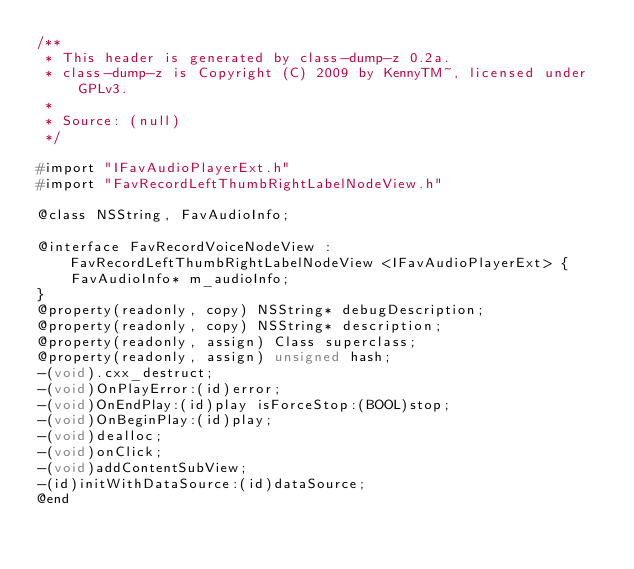Convert code to text. <code><loc_0><loc_0><loc_500><loc_500><_C_>/**
 * This header is generated by class-dump-z 0.2a.
 * class-dump-z is Copyright (C) 2009 by KennyTM~, licensed under GPLv3.
 *
 * Source: (null)
 */

#import "IFavAudioPlayerExt.h"
#import "FavRecordLeftThumbRightLabelNodeView.h"

@class NSString, FavAudioInfo;

@interface FavRecordVoiceNodeView : FavRecordLeftThumbRightLabelNodeView <IFavAudioPlayerExt> {
	FavAudioInfo* m_audioInfo;
}
@property(readonly, copy) NSString* debugDescription;
@property(readonly, copy) NSString* description;
@property(readonly, assign) Class superclass;
@property(readonly, assign) unsigned hash;
-(void).cxx_destruct;
-(void)OnPlayError:(id)error;
-(void)OnEndPlay:(id)play isForceStop:(BOOL)stop;
-(void)OnBeginPlay:(id)play;
-(void)dealloc;
-(void)onClick;
-(void)addContentSubView;
-(id)initWithDataSource:(id)dataSource;
@end

</code> 